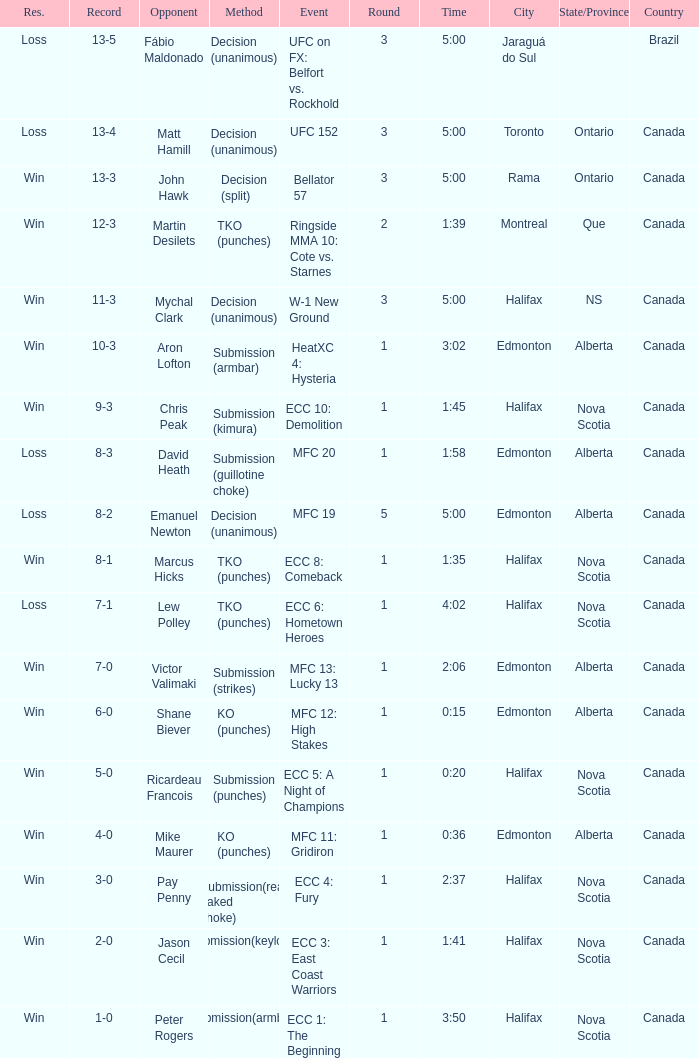Who is the opponent of the match with a win result and a time of 3:02? Aron Lofton. 